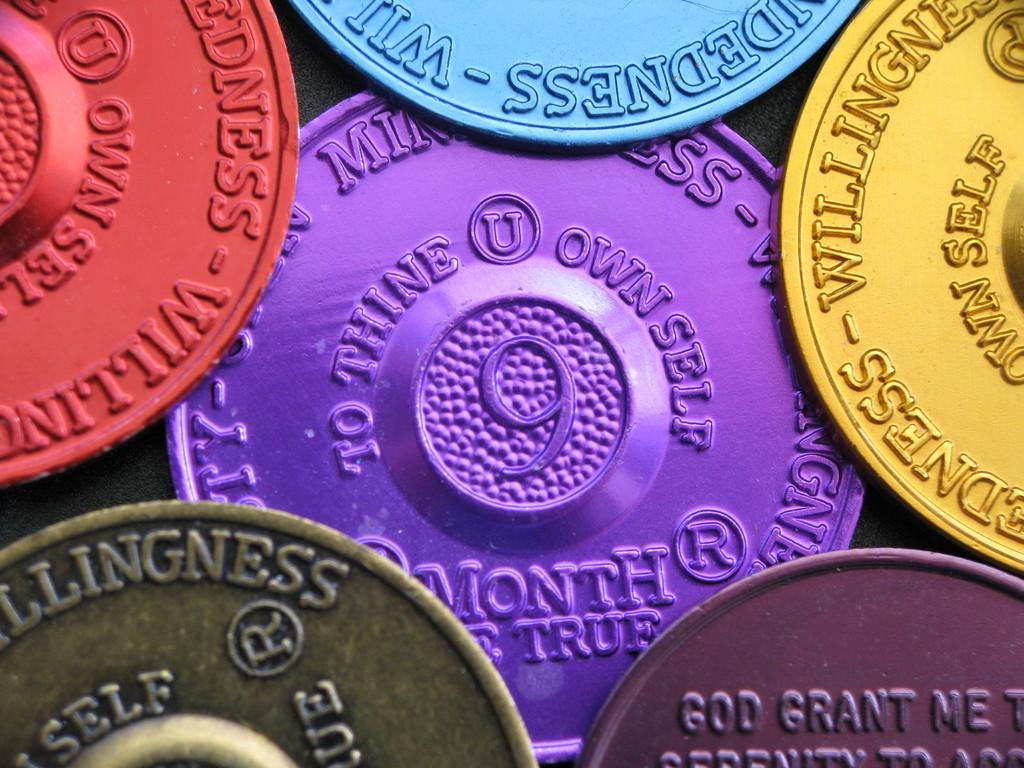<image>
Share a concise interpretation of the image provided. Many coins together with a purple one that has the number 9 on it. 